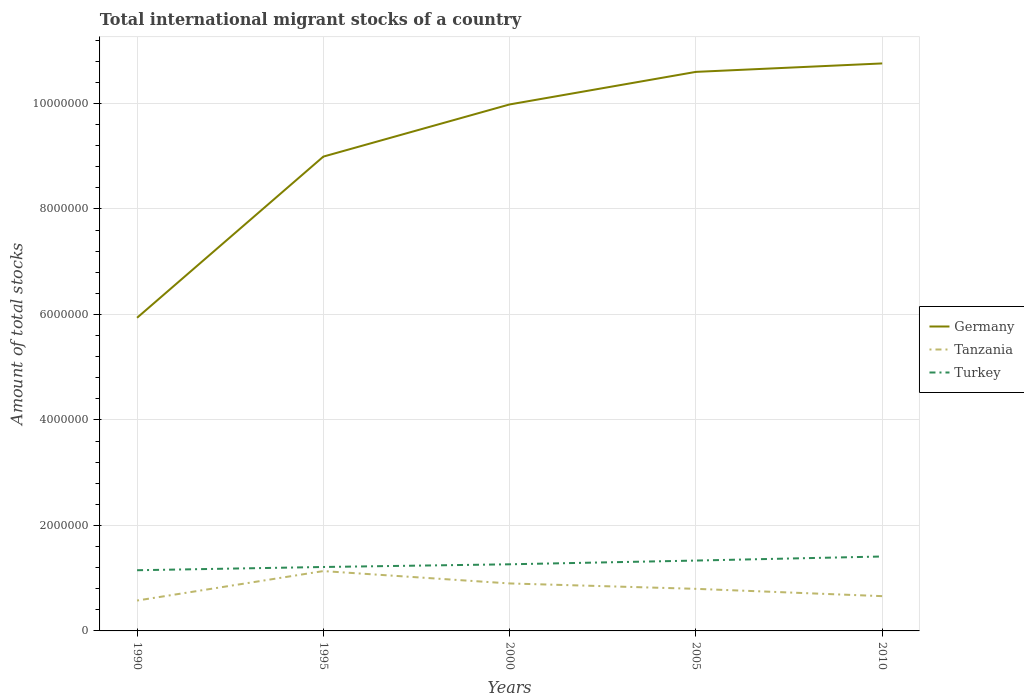Does the line corresponding to Germany intersect with the line corresponding to Tanzania?
Make the answer very short. No. Is the number of lines equal to the number of legend labels?
Make the answer very short. Yes. Across all years, what is the maximum amount of total stocks in in Turkey?
Provide a short and direct response. 1.15e+06. In which year was the amount of total stocks in in Turkey maximum?
Offer a terse response. 1990. What is the total amount of total stocks in in Tanzania in the graph?
Give a very brief answer. -5.58e+05. What is the difference between the highest and the second highest amount of total stocks in in Tanzania?
Provide a succinct answer. 5.58e+05. What is the difference between the highest and the lowest amount of total stocks in in Germany?
Give a very brief answer. 3. What is the difference between two consecutive major ticks on the Y-axis?
Your answer should be very brief. 2.00e+06. Does the graph contain any zero values?
Offer a very short reply. No. Does the graph contain grids?
Offer a very short reply. Yes. Where does the legend appear in the graph?
Offer a terse response. Center right. What is the title of the graph?
Your answer should be very brief. Total international migrant stocks of a country. Does "Iraq" appear as one of the legend labels in the graph?
Your answer should be very brief. No. What is the label or title of the Y-axis?
Your answer should be compact. Amount of total stocks. What is the Amount of total stocks of Germany in 1990?
Your answer should be compact. 5.94e+06. What is the Amount of total stocks in Tanzania in 1990?
Your response must be concise. 5.76e+05. What is the Amount of total stocks of Turkey in 1990?
Give a very brief answer. 1.15e+06. What is the Amount of total stocks in Germany in 1995?
Your answer should be very brief. 8.99e+06. What is the Amount of total stocks of Tanzania in 1995?
Offer a terse response. 1.13e+06. What is the Amount of total stocks in Turkey in 1995?
Give a very brief answer. 1.21e+06. What is the Amount of total stocks in Germany in 2000?
Offer a very short reply. 9.98e+06. What is the Amount of total stocks in Tanzania in 2000?
Give a very brief answer. 9.00e+05. What is the Amount of total stocks in Turkey in 2000?
Give a very brief answer. 1.26e+06. What is the Amount of total stocks of Germany in 2005?
Provide a succinct answer. 1.06e+07. What is the Amount of total stocks in Tanzania in 2005?
Ensure brevity in your answer.  7.98e+05. What is the Amount of total stocks in Turkey in 2005?
Offer a very short reply. 1.33e+06. What is the Amount of total stocks in Germany in 2010?
Ensure brevity in your answer.  1.08e+07. What is the Amount of total stocks in Tanzania in 2010?
Give a very brief answer. 6.59e+05. What is the Amount of total stocks of Turkey in 2010?
Offer a terse response. 1.41e+06. Across all years, what is the maximum Amount of total stocks of Germany?
Offer a very short reply. 1.08e+07. Across all years, what is the maximum Amount of total stocks in Tanzania?
Keep it short and to the point. 1.13e+06. Across all years, what is the maximum Amount of total stocks in Turkey?
Give a very brief answer. 1.41e+06. Across all years, what is the minimum Amount of total stocks of Germany?
Offer a very short reply. 5.94e+06. Across all years, what is the minimum Amount of total stocks of Tanzania?
Provide a short and direct response. 5.76e+05. Across all years, what is the minimum Amount of total stocks of Turkey?
Make the answer very short. 1.15e+06. What is the total Amount of total stocks in Germany in the graph?
Provide a succinct answer. 4.63e+07. What is the total Amount of total stocks in Tanzania in the graph?
Give a very brief answer. 4.07e+06. What is the total Amount of total stocks in Turkey in the graph?
Make the answer very short. 6.37e+06. What is the difference between the Amount of total stocks of Germany in 1990 and that in 1995?
Offer a terse response. -3.06e+06. What is the difference between the Amount of total stocks of Tanzania in 1990 and that in 1995?
Your answer should be compact. -5.58e+05. What is the difference between the Amount of total stocks of Turkey in 1990 and that in 1995?
Your answer should be very brief. -6.14e+04. What is the difference between the Amount of total stocks in Germany in 1990 and that in 2000?
Give a very brief answer. -4.04e+06. What is the difference between the Amount of total stocks of Tanzania in 1990 and that in 2000?
Provide a short and direct response. -3.24e+05. What is the difference between the Amount of total stocks in Turkey in 1990 and that in 2000?
Provide a succinct answer. -1.13e+05. What is the difference between the Amount of total stocks of Germany in 1990 and that in 2005?
Provide a short and direct response. -4.66e+06. What is the difference between the Amount of total stocks of Tanzania in 1990 and that in 2005?
Offer a very short reply. -2.22e+05. What is the difference between the Amount of total stocks in Turkey in 1990 and that in 2005?
Your response must be concise. -1.83e+05. What is the difference between the Amount of total stocks of Germany in 1990 and that in 2010?
Offer a terse response. -4.82e+06. What is the difference between the Amount of total stocks of Tanzania in 1990 and that in 2010?
Give a very brief answer. -8.32e+04. What is the difference between the Amount of total stocks in Turkey in 1990 and that in 2010?
Make the answer very short. -2.60e+05. What is the difference between the Amount of total stocks in Germany in 1995 and that in 2000?
Your answer should be very brief. -9.89e+05. What is the difference between the Amount of total stocks of Tanzania in 1995 and that in 2000?
Your answer should be compact. 2.34e+05. What is the difference between the Amount of total stocks of Turkey in 1995 and that in 2000?
Give a very brief answer. -5.13e+04. What is the difference between the Amount of total stocks in Germany in 1995 and that in 2005?
Ensure brevity in your answer.  -1.61e+06. What is the difference between the Amount of total stocks in Tanzania in 1995 and that in 2005?
Provide a succinct answer. 3.37e+05. What is the difference between the Amount of total stocks in Turkey in 1995 and that in 2005?
Your answer should be compact. -1.22e+05. What is the difference between the Amount of total stocks in Germany in 1995 and that in 2010?
Ensure brevity in your answer.  -1.77e+06. What is the difference between the Amount of total stocks of Tanzania in 1995 and that in 2010?
Your response must be concise. 4.75e+05. What is the difference between the Amount of total stocks in Turkey in 1995 and that in 2010?
Keep it short and to the point. -1.99e+05. What is the difference between the Amount of total stocks in Germany in 2000 and that in 2005?
Your answer should be compact. -6.17e+05. What is the difference between the Amount of total stocks of Tanzania in 2000 and that in 2005?
Provide a short and direct response. 1.02e+05. What is the difference between the Amount of total stocks in Turkey in 2000 and that in 2005?
Keep it short and to the point. -7.07e+04. What is the difference between the Amount of total stocks in Germany in 2000 and that in 2010?
Provide a succinct answer. -7.77e+05. What is the difference between the Amount of total stocks of Tanzania in 2000 and that in 2010?
Offer a terse response. 2.41e+05. What is the difference between the Amount of total stocks in Turkey in 2000 and that in 2010?
Offer a terse response. -1.48e+05. What is the difference between the Amount of total stocks in Germany in 2005 and that in 2010?
Provide a succinct answer. -1.60e+05. What is the difference between the Amount of total stocks of Tanzania in 2005 and that in 2010?
Offer a terse response. 1.38e+05. What is the difference between the Amount of total stocks of Turkey in 2005 and that in 2010?
Ensure brevity in your answer.  -7.71e+04. What is the difference between the Amount of total stocks in Germany in 1990 and the Amount of total stocks in Tanzania in 1995?
Ensure brevity in your answer.  4.80e+06. What is the difference between the Amount of total stocks of Germany in 1990 and the Amount of total stocks of Turkey in 1995?
Offer a very short reply. 4.72e+06. What is the difference between the Amount of total stocks of Tanzania in 1990 and the Amount of total stocks of Turkey in 1995?
Offer a terse response. -6.36e+05. What is the difference between the Amount of total stocks of Germany in 1990 and the Amount of total stocks of Tanzania in 2000?
Your answer should be very brief. 5.04e+06. What is the difference between the Amount of total stocks of Germany in 1990 and the Amount of total stocks of Turkey in 2000?
Your answer should be compact. 4.67e+06. What is the difference between the Amount of total stocks of Tanzania in 1990 and the Amount of total stocks of Turkey in 2000?
Your answer should be very brief. -6.87e+05. What is the difference between the Amount of total stocks in Germany in 1990 and the Amount of total stocks in Tanzania in 2005?
Offer a very short reply. 5.14e+06. What is the difference between the Amount of total stocks in Germany in 1990 and the Amount of total stocks in Turkey in 2005?
Your response must be concise. 4.60e+06. What is the difference between the Amount of total stocks in Tanzania in 1990 and the Amount of total stocks in Turkey in 2005?
Give a very brief answer. -7.58e+05. What is the difference between the Amount of total stocks in Germany in 1990 and the Amount of total stocks in Tanzania in 2010?
Ensure brevity in your answer.  5.28e+06. What is the difference between the Amount of total stocks in Germany in 1990 and the Amount of total stocks in Turkey in 2010?
Your answer should be very brief. 4.53e+06. What is the difference between the Amount of total stocks of Tanzania in 1990 and the Amount of total stocks of Turkey in 2010?
Give a very brief answer. -8.35e+05. What is the difference between the Amount of total stocks of Germany in 1995 and the Amount of total stocks of Tanzania in 2000?
Offer a terse response. 8.09e+06. What is the difference between the Amount of total stocks of Germany in 1995 and the Amount of total stocks of Turkey in 2000?
Provide a succinct answer. 7.73e+06. What is the difference between the Amount of total stocks of Tanzania in 1995 and the Amount of total stocks of Turkey in 2000?
Make the answer very short. -1.29e+05. What is the difference between the Amount of total stocks of Germany in 1995 and the Amount of total stocks of Tanzania in 2005?
Provide a short and direct response. 8.19e+06. What is the difference between the Amount of total stocks of Germany in 1995 and the Amount of total stocks of Turkey in 2005?
Make the answer very short. 7.66e+06. What is the difference between the Amount of total stocks in Tanzania in 1995 and the Amount of total stocks in Turkey in 2005?
Your response must be concise. -1.99e+05. What is the difference between the Amount of total stocks in Germany in 1995 and the Amount of total stocks in Tanzania in 2010?
Keep it short and to the point. 8.33e+06. What is the difference between the Amount of total stocks of Germany in 1995 and the Amount of total stocks of Turkey in 2010?
Provide a succinct answer. 7.58e+06. What is the difference between the Amount of total stocks of Tanzania in 1995 and the Amount of total stocks of Turkey in 2010?
Provide a short and direct response. -2.77e+05. What is the difference between the Amount of total stocks of Germany in 2000 and the Amount of total stocks of Tanzania in 2005?
Your answer should be compact. 9.18e+06. What is the difference between the Amount of total stocks of Germany in 2000 and the Amount of total stocks of Turkey in 2005?
Keep it short and to the point. 8.65e+06. What is the difference between the Amount of total stocks in Tanzania in 2000 and the Amount of total stocks in Turkey in 2005?
Your answer should be very brief. -4.34e+05. What is the difference between the Amount of total stocks of Germany in 2000 and the Amount of total stocks of Tanzania in 2010?
Keep it short and to the point. 9.32e+06. What is the difference between the Amount of total stocks in Germany in 2000 and the Amount of total stocks in Turkey in 2010?
Offer a terse response. 8.57e+06. What is the difference between the Amount of total stocks of Tanzania in 2000 and the Amount of total stocks of Turkey in 2010?
Make the answer very short. -5.11e+05. What is the difference between the Amount of total stocks in Germany in 2005 and the Amount of total stocks in Tanzania in 2010?
Give a very brief answer. 9.94e+06. What is the difference between the Amount of total stocks in Germany in 2005 and the Amount of total stocks in Turkey in 2010?
Your answer should be very brief. 9.19e+06. What is the difference between the Amount of total stocks in Tanzania in 2005 and the Amount of total stocks in Turkey in 2010?
Your answer should be very brief. -6.13e+05. What is the average Amount of total stocks of Germany per year?
Provide a short and direct response. 9.25e+06. What is the average Amount of total stocks of Tanzania per year?
Keep it short and to the point. 8.13e+05. What is the average Amount of total stocks of Turkey per year?
Give a very brief answer. 1.27e+06. In the year 1990, what is the difference between the Amount of total stocks of Germany and Amount of total stocks of Tanzania?
Give a very brief answer. 5.36e+06. In the year 1990, what is the difference between the Amount of total stocks of Germany and Amount of total stocks of Turkey?
Make the answer very short. 4.79e+06. In the year 1990, what is the difference between the Amount of total stocks of Tanzania and Amount of total stocks of Turkey?
Offer a terse response. -5.75e+05. In the year 1995, what is the difference between the Amount of total stocks of Germany and Amount of total stocks of Tanzania?
Ensure brevity in your answer.  7.86e+06. In the year 1995, what is the difference between the Amount of total stocks of Germany and Amount of total stocks of Turkey?
Offer a very short reply. 7.78e+06. In the year 1995, what is the difference between the Amount of total stocks of Tanzania and Amount of total stocks of Turkey?
Provide a short and direct response. -7.75e+04. In the year 2000, what is the difference between the Amount of total stocks of Germany and Amount of total stocks of Tanzania?
Provide a succinct answer. 9.08e+06. In the year 2000, what is the difference between the Amount of total stocks in Germany and Amount of total stocks in Turkey?
Your answer should be compact. 8.72e+06. In the year 2000, what is the difference between the Amount of total stocks of Tanzania and Amount of total stocks of Turkey?
Offer a terse response. -3.63e+05. In the year 2005, what is the difference between the Amount of total stocks in Germany and Amount of total stocks in Tanzania?
Ensure brevity in your answer.  9.80e+06. In the year 2005, what is the difference between the Amount of total stocks of Germany and Amount of total stocks of Turkey?
Keep it short and to the point. 9.26e+06. In the year 2005, what is the difference between the Amount of total stocks of Tanzania and Amount of total stocks of Turkey?
Your answer should be compact. -5.36e+05. In the year 2010, what is the difference between the Amount of total stocks in Germany and Amount of total stocks in Tanzania?
Keep it short and to the point. 1.01e+07. In the year 2010, what is the difference between the Amount of total stocks of Germany and Amount of total stocks of Turkey?
Your answer should be very brief. 9.35e+06. In the year 2010, what is the difference between the Amount of total stocks of Tanzania and Amount of total stocks of Turkey?
Give a very brief answer. -7.52e+05. What is the ratio of the Amount of total stocks of Germany in 1990 to that in 1995?
Make the answer very short. 0.66. What is the ratio of the Amount of total stocks in Tanzania in 1990 to that in 1995?
Your answer should be compact. 0.51. What is the ratio of the Amount of total stocks in Turkey in 1990 to that in 1995?
Your answer should be very brief. 0.95. What is the ratio of the Amount of total stocks of Germany in 1990 to that in 2000?
Your answer should be very brief. 0.59. What is the ratio of the Amount of total stocks of Tanzania in 1990 to that in 2000?
Make the answer very short. 0.64. What is the ratio of the Amount of total stocks in Turkey in 1990 to that in 2000?
Ensure brevity in your answer.  0.91. What is the ratio of the Amount of total stocks in Germany in 1990 to that in 2005?
Provide a short and direct response. 0.56. What is the ratio of the Amount of total stocks of Tanzania in 1990 to that in 2005?
Make the answer very short. 0.72. What is the ratio of the Amount of total stocks in Turkey in 1990 to that in 2005?
Ensure brevity in your answer.  0.86. What is the ratio of the Amount of total stocks of Germany in 1990 to that in 2010?
Offer a very short reply. 0.55. What is the ratio of the Amount of total stocks of Tanzania in 1990 to that in 2010?
Provide a short and direct response. 0.87. What is the ratio of the Amount of total stocks in Turkey in 1990 to that in 2010?
Give a very brief answer. 0.82. What is the ratio of the Amount of total stocks in Germany in 1995 to that in 2000?
Provide a succinct answer. 0.9. What is the ratio of the Amount of total stocks in Tanzania in 1995 to that in 2000?
Give a very brief answer. 1.26. What is the ratio of the Amount of total stocks in Turkey in 1995 to that in 2000?
Give a very brief answer. 0.96. What is the ratio of the Amount of total stocks of Germany in 1995 to that in 2005?
Provide a succinct answer. 0.85. What is the ratio of the Amount of total stocks in Tanzania in 1995 to that in 2005?
Your answer should be very brief. 1.42. What is the ratio of the Amount of total stocks in Turkey in 1995 to that in 2005?
Your answer should be very brief. 0.91. What is the ratio of the Amount of total stocks in Germany in 1995 to that in 2010?
Give a very brief answer. 0.84. What is the ratio of the Amount of total stocks of Tanzania in 1995 to that in 2010?
Offer a terse response. 1.72. What is the ratio of the Amount of total stocks of Turkey in 1995 to that in 2010?
Your answer should be very brief. 0.86. What is the ratio of the Amount of total stocks in Germany in 2000 to that in 2005?
Your answer should be compact. 0.94. What is the ratio of the Amount of total stocks of Tanzania in 2000 to that in 2005?
Your answer should be very brief. 1.13. What is the ratio of the Amount of total stocks in Turkey in 2000 to that in 2005?
Keep it short and to the point. 0.95. What is the ratio of the Amount of total stocks in Germany in 2000 to that in 2010?
Ensure brevity in your answer.  0.93. What is the ratio of the Amount of total stocks of Tanzania in 2000 to that in 2010?
Offer a very short reply. 1.37. What is the ratio of the Amount of total stocks of Turkey in 2000 to that in 2010?
Your answer should be very brief. 0.9. What is the ratio of the Amount of total stocks of Germany in 2005 to that in 2010?
Ensure brevity in your answer.  0.99. What is the ratio of the Amount of total stocks in Tanzania in 2005 to that in 2010?
Ensure brevity in your answer.  1.21. What is the ratio of the Amount of total stocks in Turkey in 2005 to that in 2010?
Offer a terse response. 0.95. What is the difference between the highest and the second highest Amount of total stocks of Germany?
Your response must be concise. 1.60e+05. What is the difference between the highest and the second highest Amount of total stocks in Tanzania?
Provide a short and direct response. 2.34e+05. What is the difference between the highest and the second highest Amount of total stocks of Turkey?
Offer a terse response. 7.71e+04. What is the difference between the highest and the lowest Amount of total stocks of Germany?
Your answer should be compact. 4.82e+06. What is the difference between the highest and the lowest Amount of total stocks in Tanzania?
Your answer should be compact. 5.58e+05. What is the difference between the highest and the lowest Amount of total stocks in Turkey?
Make the answer very short. 2.60e+05. 